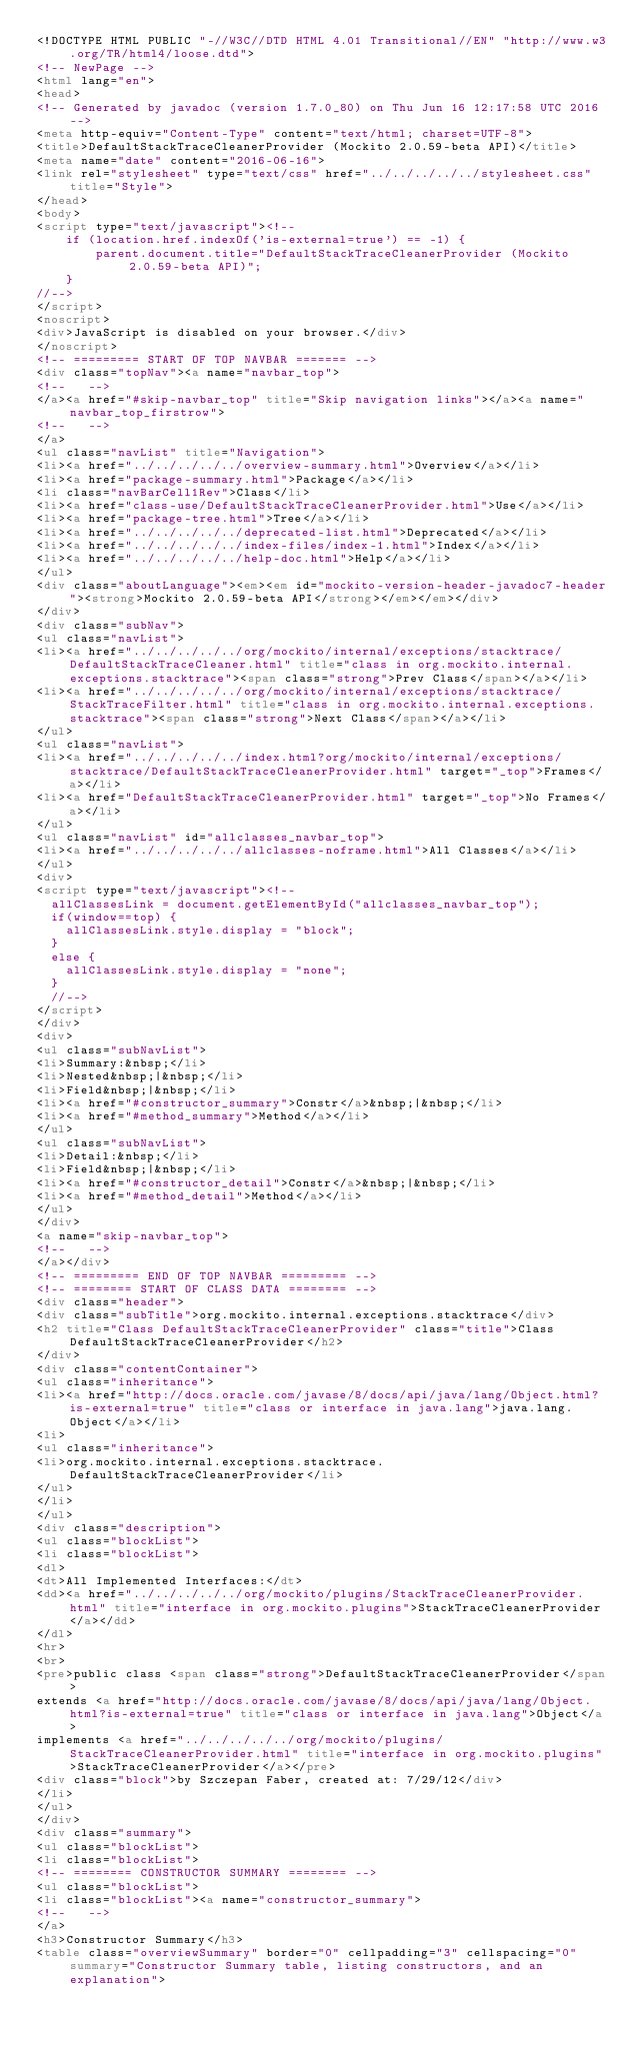<code> <loc_0><loc_0><loc_500><loc_500><_HTML_><!DOCTYPE HTML PUBLIC "-//W3C//DTD HTML 4.01 Transitional//EN" "http://www.w3.org/TR/html4/loose.dtd">
<!-- NewPage -->
<html lang="en">
<head>
<!-- Generated by javadoc (version 1.7.0_80) on Thu Jun 16 12:17:58 UTC 2016 -->
<meta http-equiv="Content-Type" content="text/html; charset=UTF-8">
<title>DefaultStackTraceCleanerProvider (Mockito 2.0.59-beta API)</title>
<meta name="date" content="2016-06-16">
<link rel="stylesheet" type="text/css" href="../../../../../stylesheet.css" title="Style">
</head>
<body>
<script type="text/javascript"><!--
    if (location.href.indexOf('is-external=true') == -1) {
        parent.document.title="DefaultStackTraceCleanerProvider (Mockito 2.0.59-beta API)";
    }
//-->
</script>
<noscript>
<div>JavaScript is disabled on your browser.</div>
</noscript>
<!-- ========= START OF TOP NAVBAR ======= -->
<div class="topNav"><a name="navbar_top">
<!--   -->
</a><a href="#skip-navbar_top" title="Skip navigation links"></a><a name="navbar_top_firstrow">
<!--   -->
</a>
<ul class="navList" title="Navigation">
<li><a href="../../../../../overview-summary.html">Overview</a></li>
<li><a href="package-summary.html">Package</a></li>
<li class="navBarCell1Rev">Class</li>
<li><a href="class-use/DefaultStackTraceCleanerProvider.html">Use</a></li>
<li><a href="package-tree.html">Tree</a></li>
<li><a href="../../../../../deprecated-list.html">Deprecated</a></li>
<li><a href="../../../../../index-files/index-1.html">Index</a></li>
<li><a href="../../../../../help-doc.html">Help</a></li>
</ul>
<div class="aboutLanguage"><em><em id="mockito-version-header-javadoc7-header"><strong>Mockito 2.0.59-beta API</strong></em></em></div>
</div>
<div class="subNav">
<ul class="navList">
<li><a href="../../../../../org/mockito/internal/exceptions/stacktrace/DefaultStackTraceCleaner.html" title="class in org.mockito.internal.exceptions.stacktrace"><span class="strong">Prev Class</span></a></li>
<li><a href="../../../../../org/mockito/internal/exceptions/stacktrace/StackTraceFilter.html" title="class in org.mockito.internal.exceptions.stacktrace"><span class="strong">Next Class</span></a></li>
</ul>
<ul class="navList">
<li><a href="../../../../../index.html?org/mockito/internal/exceptions/stacktrace/DefaultStackTraceCleanerProvider.html" target="_top">Frames</a></li>
<li><a href="DefaultStackTraceCleanerProvider.html" target="_top">No Frames</a></li>
</ul>
<ul class="navList" id="allclasses_navbar_top">
<li><a href="../../../../../allclasses-noframe.html">All Classes</a></li>
</ul>
<div>
<script type="text/javascript"><!--
  allClassesLink = document.getElementById("allclasses_navbar_top");
  if(window==top) {
    allClassesLink.style.display = "block";
  }
  else {
    allClassesLink.style.display = "none";
  }
  //-->
</script>
</div>
<div>
<ul class="subNavList">
<li>Summary:&nbsp;</li>
<li>Nested&nbsp;|&nbsp;</li>
<li>Field&nbsp;|&nbsp;</li>
<li><a href="#constructor_summary">Constr</a>&nbsp;|&nbsp;</li>
<li><a href="#method_summary">Method</a></li>
</ul>
<ul class="subNavList">
<li>Detail:&nbsp;</li>
<li>Field&nbsp;|&nbsp;</li>
<li><a href="#constructor_detail">Constr</a>&nbsp;|&nbsp;</li>
<li><a href="#method_detail">Method</a></li>
</ul>
</div>
<a name="skip-navbar_top">
<!--   -->
</a></div>
<!-- ========= END OF TOP NAVBAR ========= -->
<!-- ======== START OF CLASS DATA ======== -->
<div class="header">
<div class="subTitle">org.mockito.internal.exceptions.stacktrace</div>
<h2 title="Class DefaultStackTraceCleanerProvider" class="title">Class DefaultStackTraceCleanerProvider</h2>
</div>
<div class="contentContainer">
<ul class="inheritance">
<li><a href="http://docs.oracle.com/javase/8/docs/api/java/lang/Object.html?is-external=true" title="class or interface in java.lang">java.lang.Object</a></li>
<li>
<ul class="inheritance">
<li>org.mockito.internal.exceptions.stacktrace.DefaultStackTraceCleanerProvider</li>
</ul>
</li>
</ul>
<div class="description">
<ul class="blockList">
<li class="blockList">
<dl>
<dt>All Implemented Interfaces:</dt>
<dd><a href="../../../../../org/mockito/plugins/StackTraceCleanerProvider.html" title="interface in org.mockito.plugins">StackTraceCleanerProvider</a></dd>
</dl>
<hr>
<br>
<pre>public class <span class="strong">DefaultStackTraceCleanerProvider</span>
extends <a href="http://docs.oracle.com/javase/8/docs/api/java/lang/Object.html?is-external=true" title="class or interface in java.lang">Object</a>
implements <a href="../../../../../org/mockito/plugins/StackTraceCleanerProvider.html" title="interface in org.mockito.plugins">StackTraceCleanerProvider</a></pre>
<div class="block">by Szczepan Faber, created at: 7/29/12</div>
</li>
</ul>
</div>
<div class="summary">
<ul class="blockList">
<li class="blockList">
<!-- ======== CONSTRUCTOR SUMMARY ======== -->
<ul class="blockList">
<li class="blockList"><a name="constructor_summary">
<!--   -->
</a>
<h3>Constructor Summary</h3>
<table class="overviewSummary" border="0" cellpadding="3" cellspacing="0" summary="Constructor Summary table, listing constructors, and an explanation"></code> 